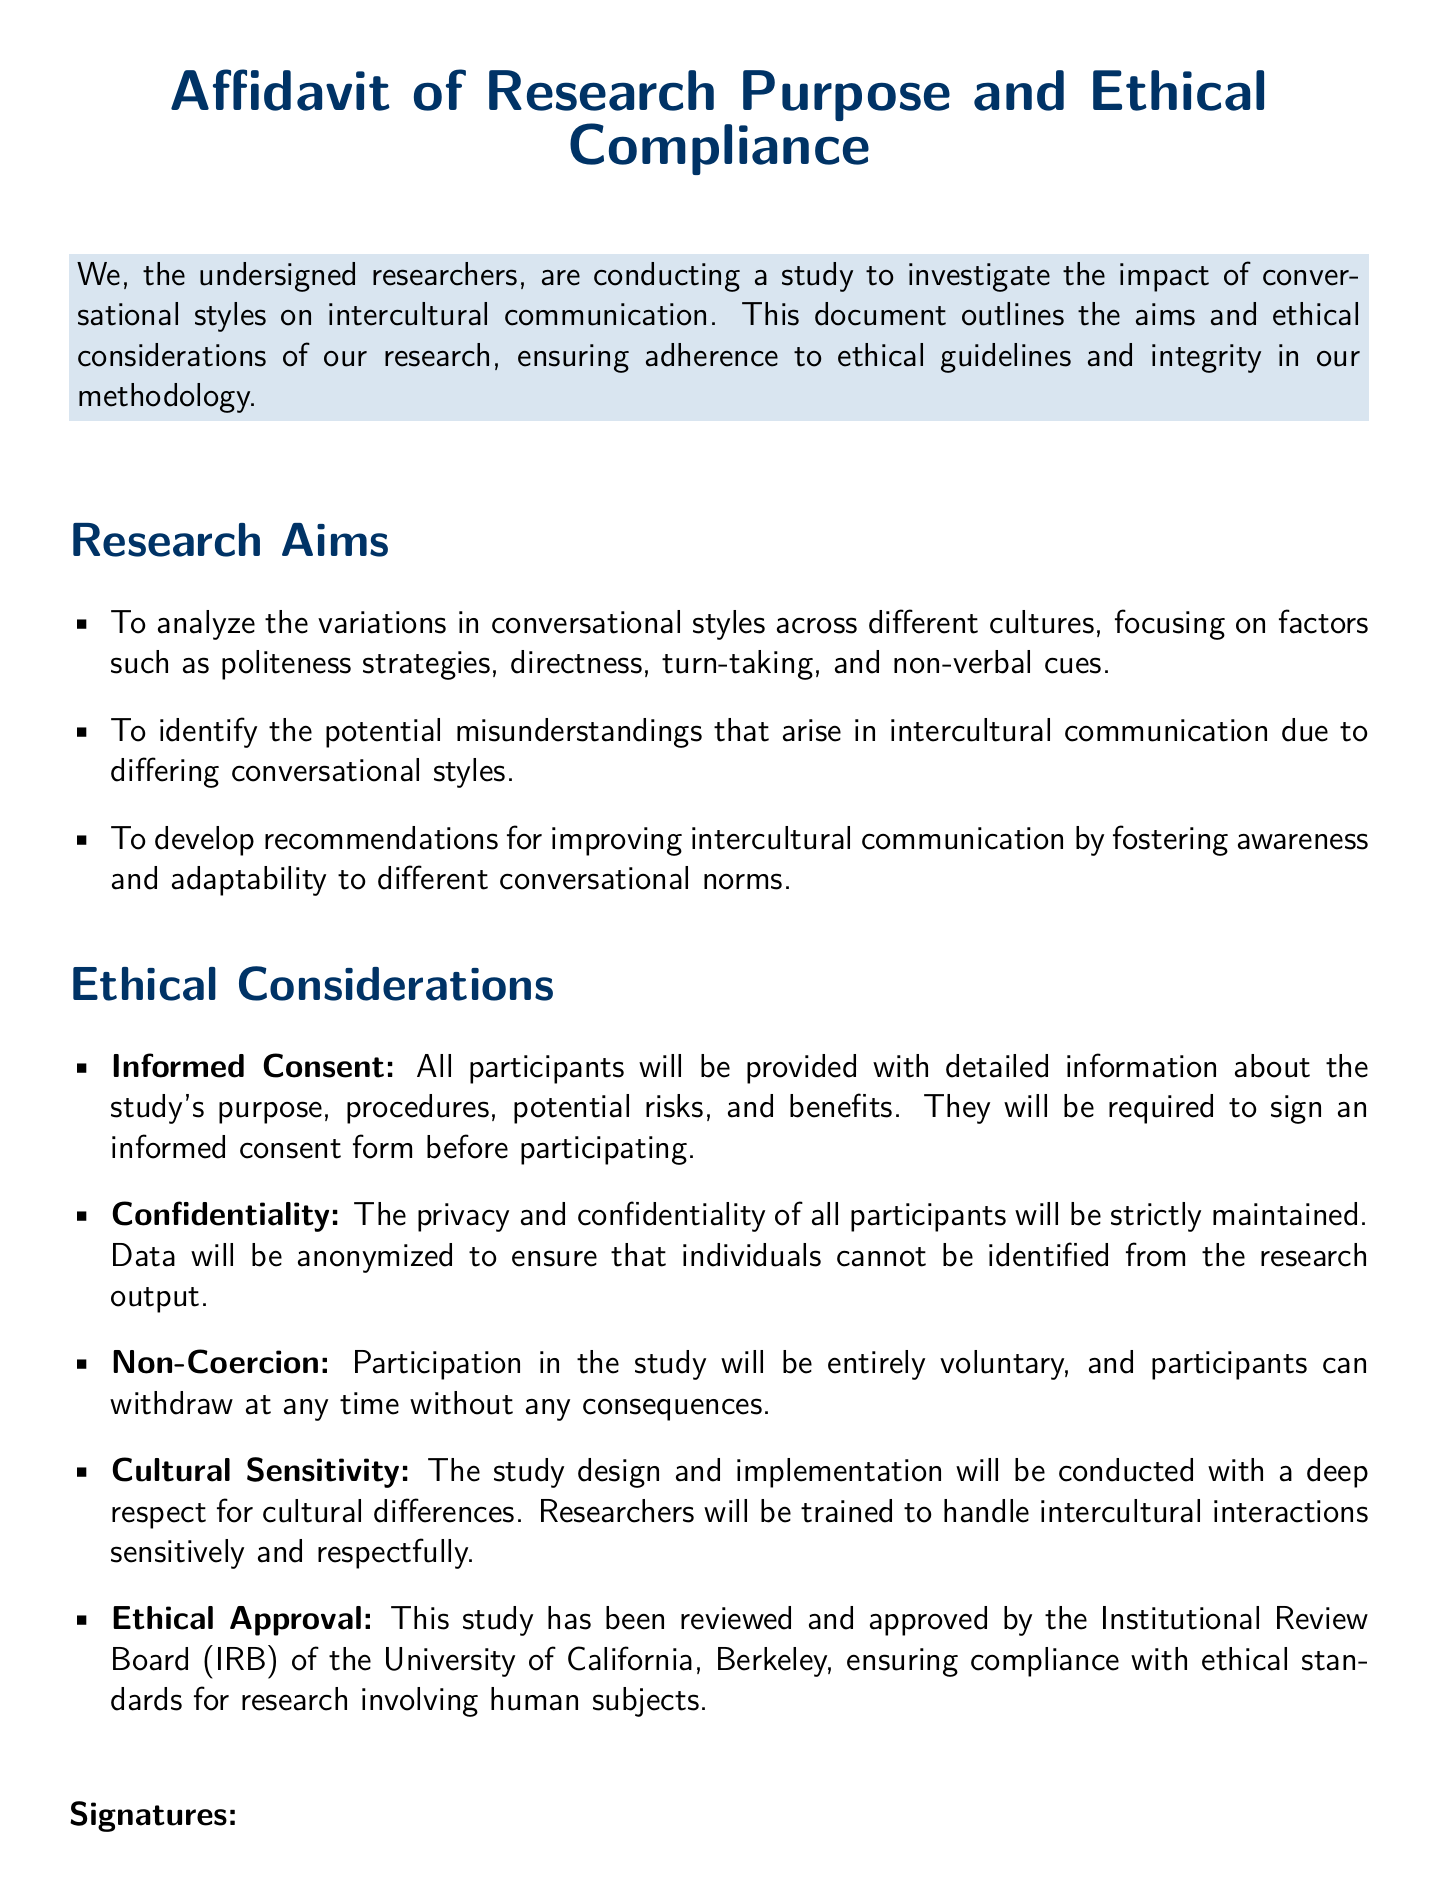What is the title of the document? The title is clearly stated at the top of the document, which outlines the purpose of the document.
Answer: Affidavit of Research Purpose and Ethical Compliance Who is the Principal Investigator? The document lists the researchers involved, including their roles and names.
Answer: Dr. Emily Sanchez What is the date of signing for the Co-Investigator? The document provides the date next to each researcher's signature.
Answer: 2023-10-01 What are the aims of the research? The document includes a section dedicated to listing the goals of the research study.
Answer: To analyze the variations in conversational styles across different cultures, focusing on factors such as politeness strategies, directness, turn-taking, and non-verbal cues What ethical consideration addresses participant privacy? The document outlines various considerations with specific headings, including the protection of participants.
Answer: Confidentiality How many researchers are involved in this study? The document lists the number of signatures, indicating the total number of researchers.
Answer: Three What is required from participants before they join the study? The document notes the essential procedural requirement for participant involvement in the study.
Answer: Informed consent What institution approved the ethical compliance of the study? The document specifies the reviewing body for the ethical standards related to the research.
Answer: University of California, Berkeley What does the document emphasize regarding participation? The text clearly states a key principle related to participant involvement in research.
Answer: Non-Coercion 